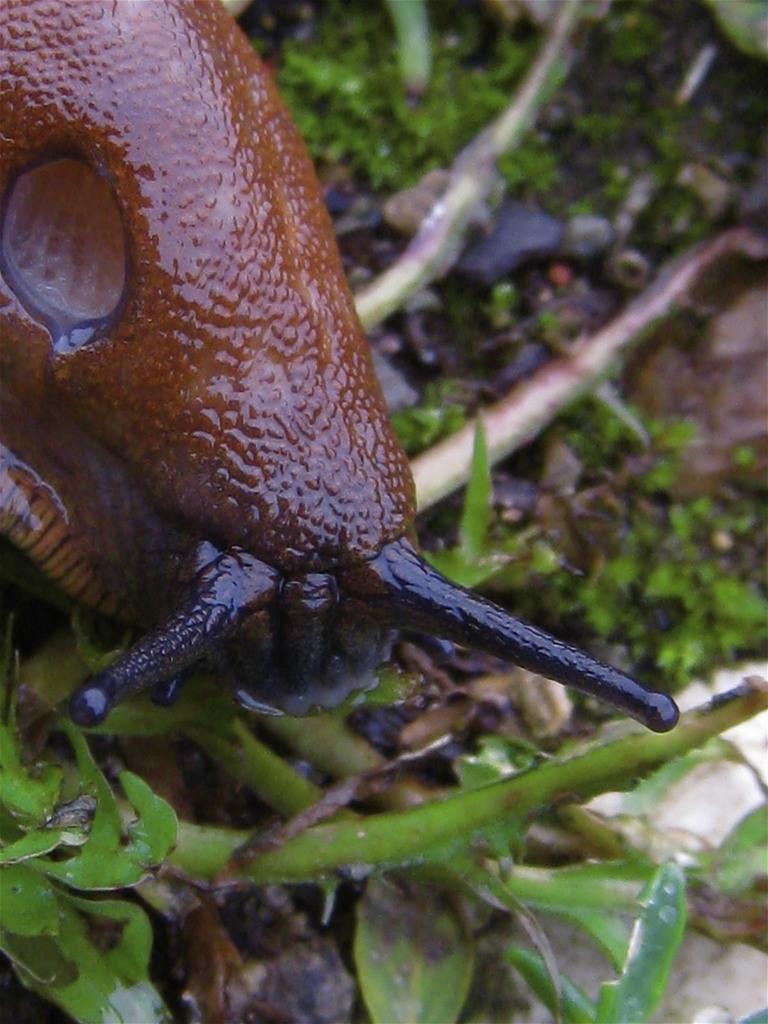In one or two sentences, can you explain what this image depicts? In this image we can see a snail on the ground, we can also see some plants. 